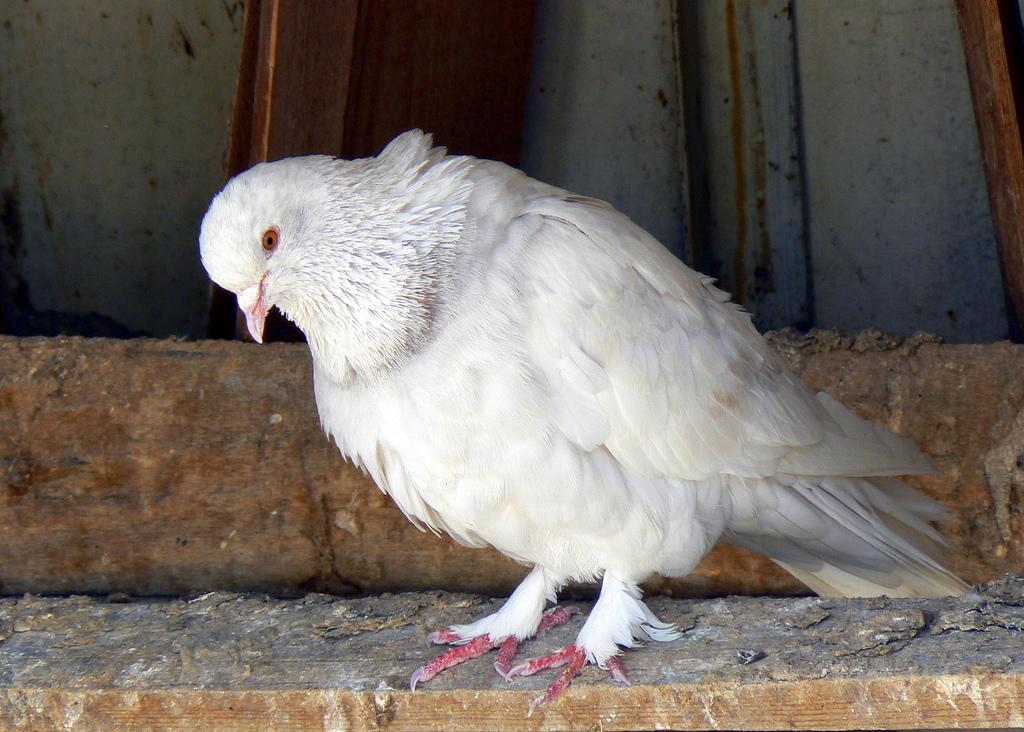What type of animal is in the image? There is a bird in the image. What is the bird sitting on? The bird is on a wooden surface. What color is the bird? The bird is white in color. What color are the bird's claws? The bird has pink color claws. What type of cart is the bird using to transport goods in the image? There is no cart present in the image, and the bird is not shown transporting goods. 